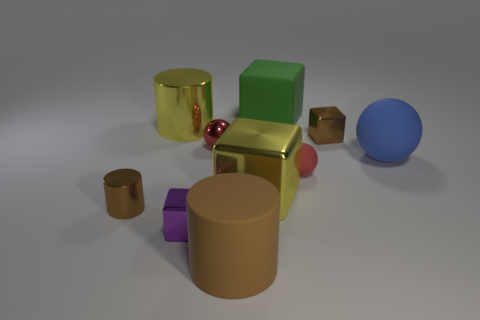What is the color of the sphere that is the same size as the yellow cylinder?
Offer a terse response. Blue. How many objects are tiny red spheres that are in front of the blue matte ball or small metallic things in front of the small red metallic sphere?
Provide a short and direct response. 3. Are there an equal number of big blue objects that are left of the yellow cylinder and tiny metal spheres?
Provide a short and direct response. No. Do the brown cylinder that is to the right of the large yellow shiny cylinder and the yellow metallic thing that is in front of the small brown metallic cube have the same size?
Offer a very short reply. Yes. What number of other objects are there of the same size as the blue thing?
Make the answer very short. 4. There is a small brown thing behind the yellow object that is on the right side of the purple object; are there any tiny matte balls behind it?
Give a very brief answer. No. Is there any other thing that is the same color as the big metallic cylinder?
Make the answer very short. Yes. What size is the cylinder that is to the right of the small purple thing?
Your answer should be compact. Large. What size is the brown object to the left of the metal cube left of the yellow block that is to the left of the tiny red rubber sphere?
Your answer should be compact. Small. The small object behind the sphere left of the large rubber block is what color?
Give a very brief answer. Brown. 